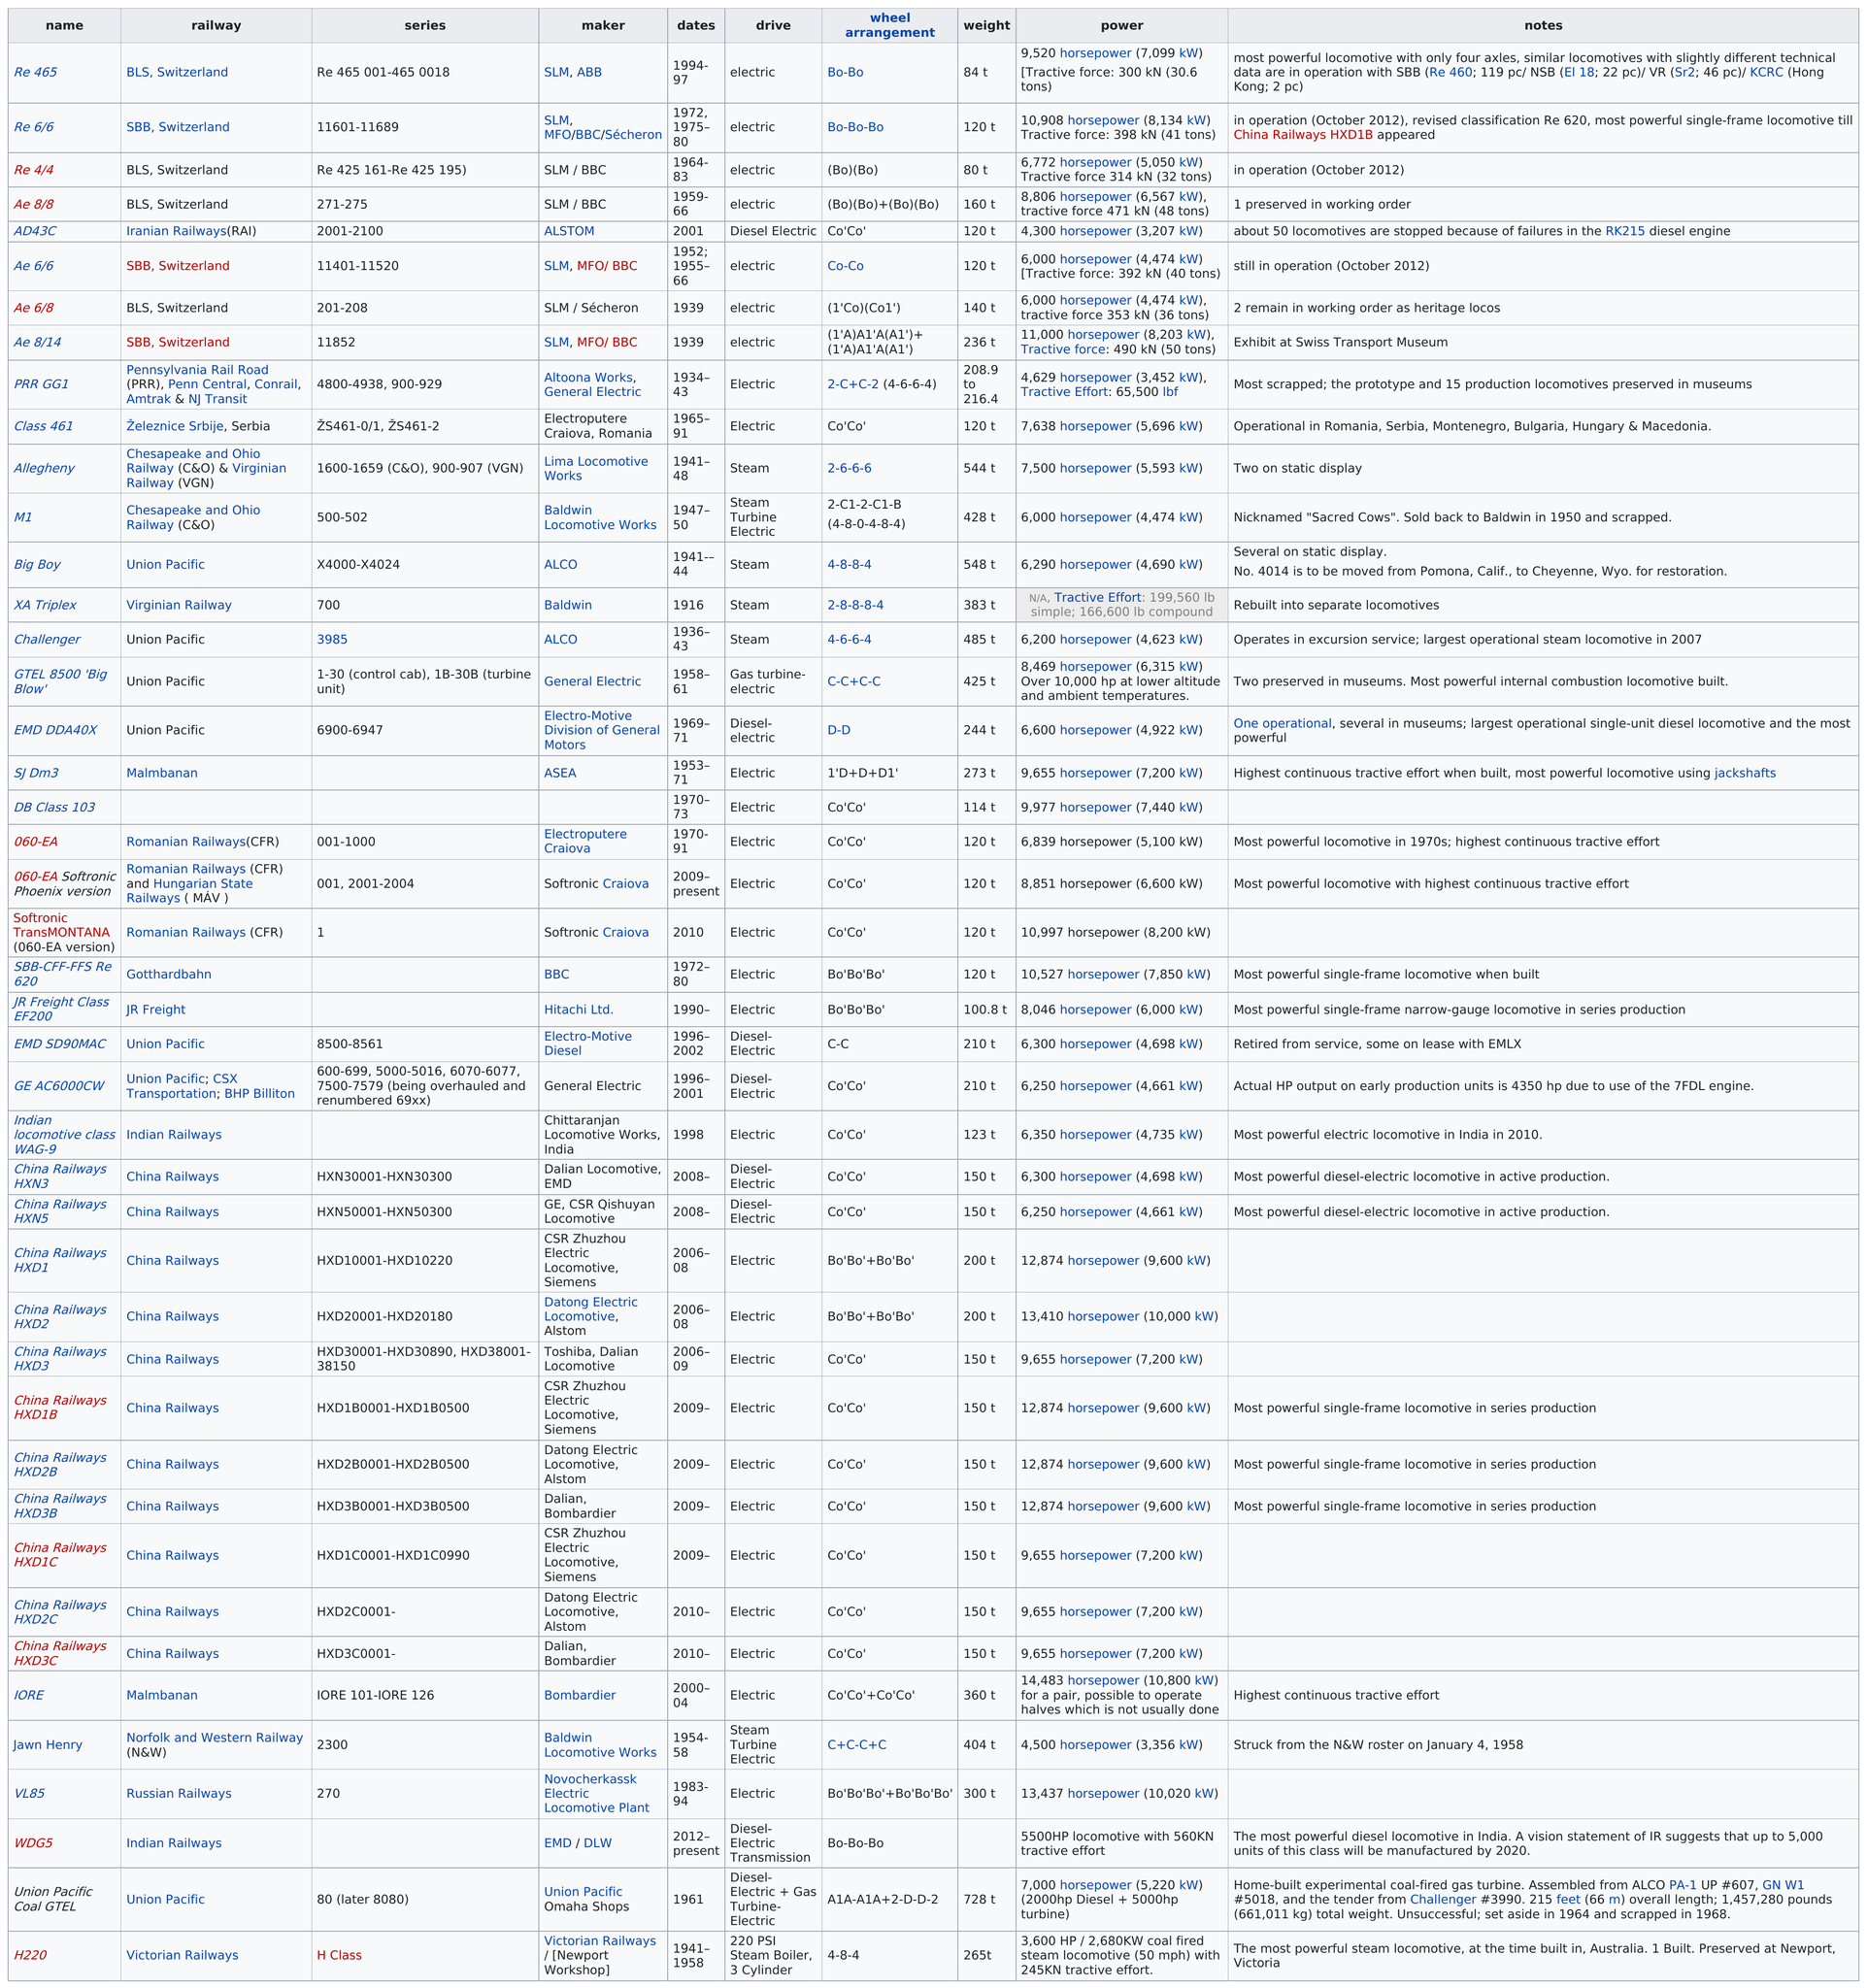Highlight a few significant elements in this photo. The list of the largest locomotives includes 44 locomotives. The weight difference between the RE 465 and the AE 6/6 is 36 tonnes. The Ae 8/8 weighs more than the Re 6/6. The H220 locomotive had the least amount of power among all the locomotives. The combined weight of the "Big Boy" and the M1 is approximately 976 tonnes. 